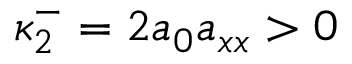<formula> <loc_0><loc_0><loc_500><loc_500>\kappa _ { 2 } ^ { - } = 2 a _ { 0 } a _ { x x } > 0</formula> 